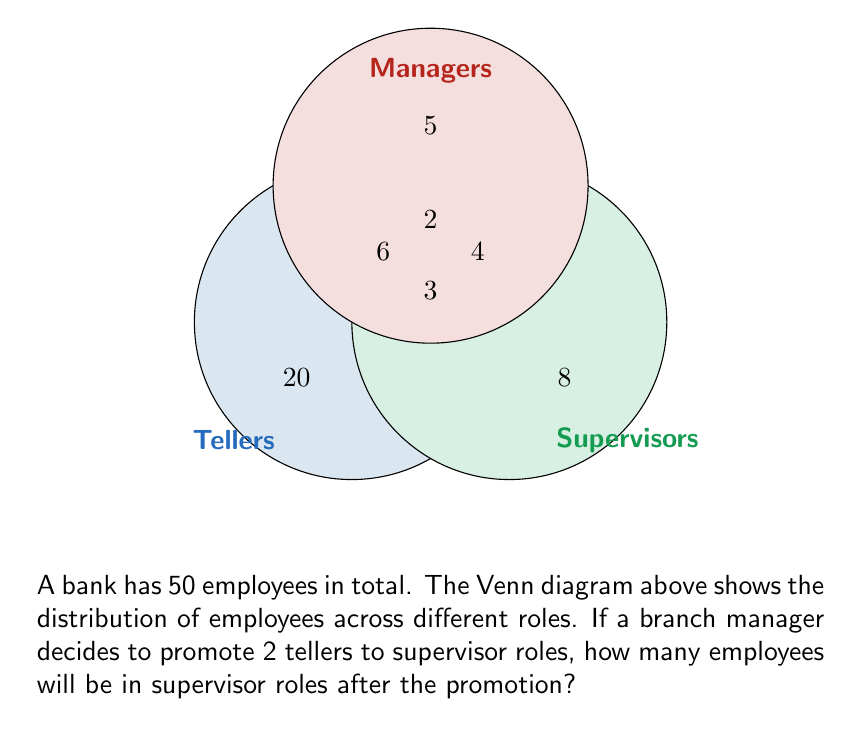Could you help me with this problem? Let's approach this step-by-step:

1) First, we need to identify the current number of supervisors:
   - There are 8 employees who are only supervisors
   - There are 4 employees who are both supervisors and managers
   - There are 3 employees who are tellers, supervisors, and managers
   - There are 2 employees who are in the center of all three circles

   Total current supervisors = $8 + 4 + 3 + 2 = 17$

2) The branch manager is promoting 2 tellers to supervisor roles. These 2 employees will move from the "Tellers only" section (20) to the section that overlaps "Tellers" and "Supervisors" (6).

3) After the promotion:
   - The number in the "Supervisors only" section (8) remains unchanged
   - The number in the "Tellers and Supervisors" section increases from 6 to 8
   - The numbers in all other sections remain the same

4) To find the total number of supervisors after the promotion, we add:
   $8 + 8 + 4 + 3 + 2 = 25$

Therefore, after the promotion, there will be 25 employees in supervisor roles.
Answer: 25 supervisors 